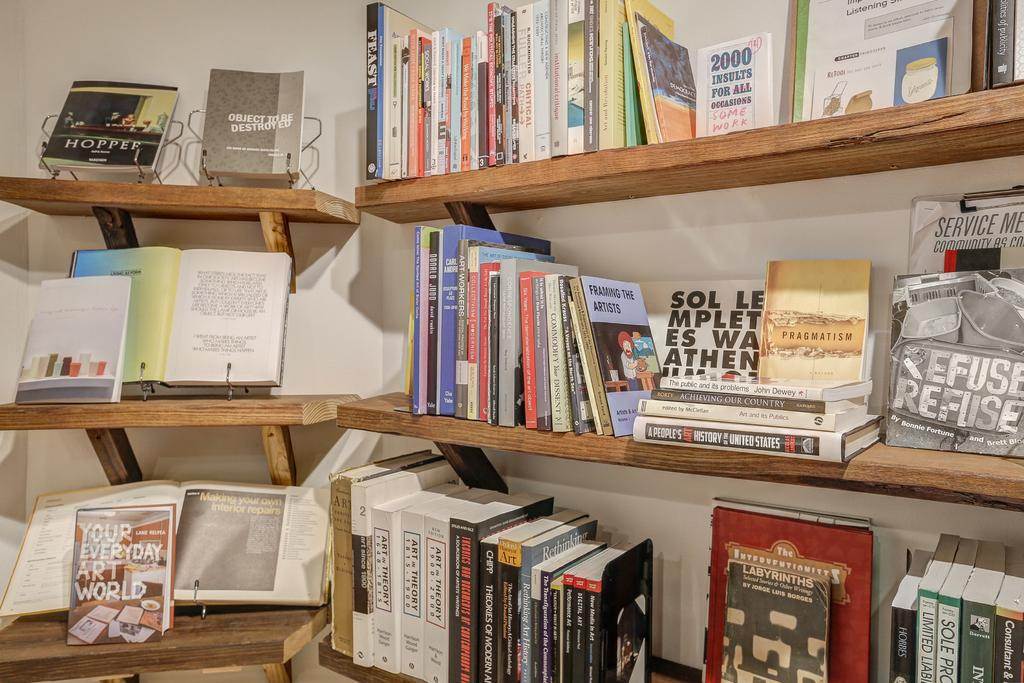What type of objects are present in the image? The image contains books. Where are the books located? The books are in bookshelves. What color is the background of the image? The background of the image is a white wall. What material are the bookshelves made of? The bookshelves are made of wood. Can you see any signs of breath on the books in the image? There is no indication of breath or any living beings in the image, as it only features books on bookshelves in front of a white wall. 